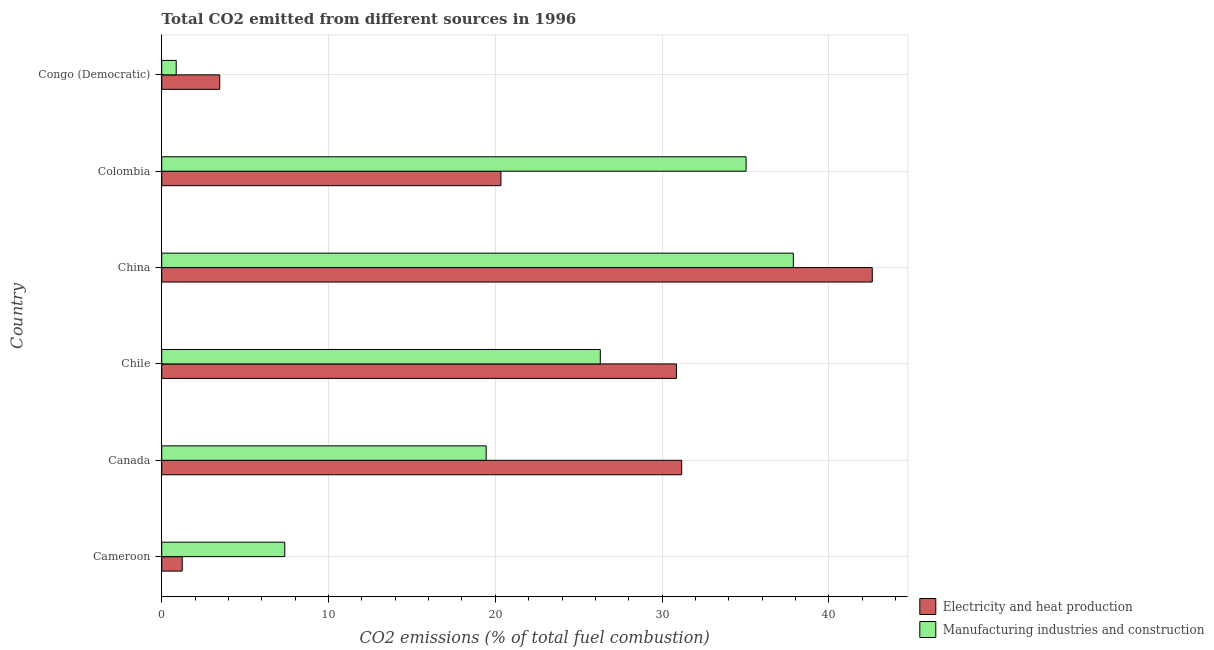How many different coloured bars are there?
Offer a very short reply. 2. How many bars are there on the 3rd tick from the bottom?
Provide a succinct answer. 2. What is the label of the 5th group of bars from the top?
Provide a short and direct response. Canada. In how many cases, is the number of bars for a given country not equal to the number of legend labels?
Keep it short and to the point. 0. What is the co2 emissions due to electricity and heat production in China?
Offer a very short reply. 42.59. Across all countries, what is the maximum co2 emissions due to electricity and heat production?
Make the answer very short. 42.59. Across all countries, what is the minimum co2 emissions due to electricity and heat production?
Give a very brief answer. 1.23. In which country was the co2 emissions due to manufacturing industries maximum?
Provide a short and direct response. China. In which country was the co2 emissions due to manufacturing industries minimum?
Offer a very short reply. Congo (Democratic). What is the total co2 emissions due to manufacturing industries in the graph?
Your answer should be very brief. 126.88. What is the difference between the co2 emissions due to electricity and heat production in Chile and that in China?
Keep it short and to the point. -11.74. What is the difference between the co2 emissions due to electricity and heat production in Cameroon and the co2 emissions due to manufacturing industries in Congo (Democratic)?
Offer a very short reply. 0.36. What is the average co2 emissions due to electricity and heat production per country?
Ensure brevity in your answer.  21.61. What is the difference between the co2 emissions due to electricity and heat production and co2 emissions due to manufacturing industries in Cameroon?
Offer a very short reply. -6.15. What is the ratio of the co2 emissions due to electricity and heat production in Colombia to that in Congo (Democratic)?
Offer a very short reply. 5.85. Is the co2 emissions due to manufacturing industries in China less than that in Colombia?
Your answer should be very brief. No. Is the difference between the co2 emissions due to electricity and heat production in China and Congo (Democratic) greater than the difference between the co2 emissions due to manufacturing industries in China and Congo (Democratic)?
Ensure brevity in your answer.  Yes. What is the difference between the highest and the second highest co2 emissions due to manufacturing industries?
Make the answer very short. 2.83. What is the difference between the highest and the lowest co2 emissions due to manufacturing industries?
Your answer should be very brief. 36.99. In how many countries, is the co2 emissions due to manufacturing industries greater than the average co2 emissions due to manufacturing industries taken over all countries?
Your response must be concise. 3. What does the 1st bar from the top in Canada represents?
Provide a short and direct response. Manufacturing industries and construction. What does the 2nd bar from the bottom in Canada represents?
Ensure brevity in your answer.  Manufacturing industries and construction. What is the difference between two consecutive major ticks on the X-axis?
Give a very brief answer. 10. Does the graph contain grids?
Your answer should be very brief. Yes. Where does the legend appear in the graph?
Make the answer very short. Bottom right. How many legend labels are there?
Give a very brief answer. 2. How are the legend labels stacked?
Provide a succinct answer. Vertical. What is the title of the graph?
Offer a terse response. Total CO2 emitted from different sources in 1996. Does "Education" appear as one of the legend labels in the graph?
Offer a very short reply. No. What is the label or title of the X-axis?
Your answer should be compact. CO2 emissions (% of total fuel combustion). What is the label or title of the Y-axis?
Keep it short and to the point. Country. What is the CO2 emissions (% of total fuel combustion) of Electricity and heat production in Cameroon?
Make the answer very short. 1.23. What is the CO2 emissions (% of total fuel combustion) in Manufacturing industries and construction in Cameroon?
Offer a terse response. 7.38. What is the CO2 emissions (% of total fuel combustion) of Electricity and heat production in Canada?
Your response must be concise. 31.17. What is the CO2 emissions (% of total fuel combustion) in Manufacturing industries and construction in Canada?
Your answer should be very brief. 19.45. What is the CO2 emissions (% of total fuel combustion) in Electricity and heat production in Chile?
Offer a very short reply. 30.85. What is the CO2 emissions (% of total fuel combustion) in Manufacturing industries and construction in Chile?
Your response must be concise. 26.29. What is the CO2 emissions (% of total fuel combustion) of Electricity and heat production in China?
Your answer should be very brief. 42.59. What is the CO2 emissions (% of total fuel combustion) in Manufacturing industries and construction in China?
Ensure brevity in your answer.  37.86. What is the CO2 emissions (% of total fuel combustion) in Electricity and heat production in Colombia?
Provide a succinct answer. 20.33. What is the CO2 emissions (% of total fuel combustion) in Manufacturing industries and construction in Colombia?
Offer a terse response. 35.03. What is the CO2 emissions (% of total fuel combustion) of Electricity and heat production in Congo (Democratic)?
Provide a short and direct response. 3.48. What is the CO2 emissions (% of total fuel combustion) of Manufacturing industries and construction in Congo (Democratic)?
Provide a succinct answer. 0.87. Across all countries, what is the maximum CO2 emissions (% of total fuel combustion) in Electricity and heat production?
Your answer should be compact. 42.59. Across all countries, what is the maximum CO2 emissions (% of total fuel combustion) of Manufacturing industries and construction?
Ensure brevity in your answer.  37.86. Across all countries, what is the minimum CO2 emissions (% of total fuel combustion) in Electricity and heat production?
Ensure brevity in your answer.  1.23. Across all countries, what is the minimum CO2 emissions (% of total fuel combustion) of Manufacturing industries and construction?
Give a very brief answer. 0.87. What is the total CO2 emissions (% of total fuel combustion) in Electricity and heat production in the graph?
Provide a short and direct response. 129.66. What is the total CO2 emissions (% of total fuel combustion) of Manufacturing industries and construction in the graph?
Provide a succinct answer. 126.88. What is the difference between the CO2 emissions (% of total fuel combustion) of Electricity and heat production in Cameroon and that in Canada?
Your answer should be very brief. -29.94. What is the difference between the CO2 emissions (% of total fuel combustion) in Manufacturing industries and construction in Cameroon and that in Canada?
Ensure brevity in your answer.  -12.07. What is the difference between the CO2 emissions (% of total fuel combustion) in Electricity and heat production in Cameroon and that in Chile?
Offer a terse response. -29.63. What is the difference between the CO2 emissions (% of total fuel combustion) of Manufacturing industries and construction in Cameroon and that in Chile?
Give a very brief answer. -18.91. What is the difference between the CO2 emissions (% of total fuel combustion) of Electricity and heat production in Cameroon and that in China?
Your answer should be very brief. -41.37. What is the difference between the CO2 emissions (% of total fuel combustion) of Manufacturing industries and construction in Cameroon and that in China?
Keep it short and to the point. -30.49. What is the difference between the CO2 emissions (% of total fuel combustion) in Electricity and heat production in Cameroon and that in Colombia?
Provide a succinct answer. -19.1. What is the difference between the CO2 emissions (% of total fuel combustion) of Manufacturing industries and construction in Cameroon and that in Colombia?
Your answer should be very brief. -27.66. What is the difference between the CO2 emissions (% of total fuel combustion) in Electricity and heat production in Cameroon and that in Congo (Democratic)?
Give a very brief answer. -2.25. What is the difference between the CO2 emissions (% of total fuel combustion) of Manufacturing industries and construction in Cameroon and that in Congo (Democratic)?
Make the answer very short. 6.51. What is the difference between the CO2 emissions (% of total fuel combustion) in Electricity and heat production in Canada and that in Chile?
Provide a short and direct response. 0.32. What is the difference between the CO2 emissions (% of total fuel combustion) in Manufacturing industries and construction in Canada and that in Chile?
Offer a terse response. -6.84. What is the difference between the CO2 emissions (% of total fuel combustion) of Electricity and heat production in Canada and that in China?
Your answer should be very brief. -11.42. What is the difference between the CO2 emissions (% of total fuel combustion) in Manufacturing industries and construction in Canada and that in China?
Provide a succinct answer. -18.41. What is the difference between the CO2 emissions (% of total fuel combustion) of Electricity and heat production in Canada and that in Colombia?
Your response must be concise. 10.84. What is the difference between the CO2 emissions (% of total fuel combustion) in Manufacturing industries and construction in Canada and that in Colombia?
Give a very brief answer. -15.58. What is the difference between the CO2 emissions (% of total fuel combustion) in Electricity and heat production in Canada and that in Congo (Democratic)?
Ensure brevity in your answer.  27.69. What is the difference between the CO2 emissions (% of total fuel combustion) in Manufacturing industries and construction in Canada and that in Congo (Democratic)?
Give a very brief answer. 18.58. What is the difference between the CO2 emissions (% of total fuel combustion) of Electricity and heat production in Chile and that in China?
Make the answer very short. -11.74. What is the difference between the CO2 emissions (% of total fuel combustion) of Manufacturing industries and construction in Chile and that in China?
Your answer should be very brief. -11.57. What is the difference between the CO2 emissions (% of total fuel combustion) in Electricity and heat production in Chile and that in Colombia?
Offer a very short reply. 10.52. What is the difference between the CO2 emissions (% of total fuel combustion) of Manufacturing industries and construction in Chile and that in Colombia?
Give a very brief answer. -8.74. What is the difference between the CO2 emissions (% of total fuel combustion) in Electricity and heat production in Chile and that in Congo (Democratic)?
Keep it short and to the point. 27.38. What is the difference between the CO2 emissions (% of total fuel combustion) in Manufacturing industries and construction in Chile and that in Congo (Democratic)?
Your response must be concise. 25.42. What is the difference between the CO2 emissions (% of total fuel combustion) in Electricity and heat production in China and that in Colombia?
Your answer should be very brief. 22.26. What is the difference between the CO2 emissions (% of total fuel combustion) in Manufacturing industries and construction in China and that in Colombia?
Give a very brief answer. 2.83. What is the difference between the CO2 emissions (% of total fuel combustion) in Electricity and heat production in China and that in Congo (Democratic)?
Provide a succinct answer. 39.12. What is the difference between the CO2 emissions (% of total fuel combustion) in Manufacturing industries and construction in China and that in Congo (Democratic)?
Give a very brief answer. 36.99. What is the difference between the CO2 emissions (% of total fuel combustion) of Electricity and heat production in Colombia and that in Congo (Democratic)?
Your answer should be compact. 16.86. What is the difference between the CO2 emissions (% of total fuel combustion) of Manufacturing industries and construction in Colombia and that in Congo (Democratic)?
Your response must be concise. 34.16. What is the difference between the CO2 emissions (% of total fuel combustion) in Electricity and heat production in Cameroon and the CO2 emissions (% of total fuel combustion) in Manufacturing industries and construction in Canada?
Offer a very short reply. -18.22. What is the difference between the CO2 emissions (% of total fuel combustion) in Electricity and heat production in Cameroon and the CO2 emissions (% of total fuel combustion) in Manufacturing industries and construction in Chile?
Provide a succinct answer. -25.06. What is the difference between the CO2 emissions (% of total fuel combustion) of Electricity and heat production in Cameroon and the CO2 emissions (% of total fuel combustion) of Manufacturing industries and construction in China?
Offer a terse response. -36.63. What is the difference between the CO2 emissions (% of total fuel combustion) in Electricity and heat production in Cameroon and the CO2 emissions (% of total fuel combustion) in Manufacturing industries and construction in Colombia?
Offer a very short reply. -33.8. What is the difference between the CO2 emissions (% of total fuel combustion) in Electricity and heat production in Cameroon and the CO2 emissions (% of total fuel combustion) in Manufacturing industries and construction in Congo (Democratic)?
Your answer should be compact. 0.36. What is the difference between the CO2 emissions (% of total fuel combustion) of Electricity and heat production in Canada and the CO2 emissions (% of total fuel combustion) of Manufacturing industries and construction in Chile?
Provide a succinct answer. 4.88. What is the difference between the CO2 emissions (% of total fuel combustion) of Electricity and heat production in Canada and the CO2 emissions (% of total fuel combustion) of Manufacturing industries and construction in China?
Provide a short and direct response. -6.69. What is the difference between the CO2 emissions (% of total fuel combustion) of Electricity and heat production in Canada and the CO2 emissions (% of total fuel combustion) of Manufacturing industries and construction in Colombia?
Your response must be concise. -3.86. What is the difference between the CO2 emissions (% of total fuel combustion) in Electricity and heat production in Canada and the CO2 emissions (% of total fuel combustion) in Manufacturing industries and construction in Congo (Democratic)?
Provide a short and direct response. 30.3. What is the difference between the CO2 emissions (% of total fuel combustion) in Electricity and heat production in Chile and the CO2 emissions (% of total fuel combustion) in Manufacturing industries and construction in China?
Give a very brief answer. -7.01. What is the difference between the CO2 emissions (% of total fuel combustion) in Electricity and heat production in Chile and the CO2 emissions (% of total fuel combustion) in Manufacturing industries and construction in Colombia?
Ensure brevity in your answer.  -4.18. What is the difference between the CO2 emissions (% of total fuel combustion) of Electricity and heat production in Chile and the CO2 emissions (% of total fuel combustion) of Manufacturing industries and construction in Congo (Democratic)?
Your answer should be compact. 29.99. What is the difference between the CO2 emissions (% of total fuel combustion) of Electricity and heat production in China and the CO2 emissions (% of total fuel combustion) of Manufacturing industries and construction in Colombia?
Your answer should be very brief. 7.56. What is the difference between the CO2 emissions (% of total fuel combustion) of Electricity and heat production in China and the CO2 emissions (% of total fuel combustion) of Manufacturing industries and construction in Congo (Democratic)?
Your answer should be very brief. 41.73. What is the difference between the CO2 emissions (% of total fuel combustion) in Electricity and heat production in Colombia and the CO2 emissions (% of total fuel combustion) in Manufacturing industries and construction in Congo (Democratic)?
Give a very brief answer. 19.46. What is the average CO2 emissions (% of total fuel combustion) in Electricity and heat production per country?
Provide a short and direct response. 21.61. What is the average CO2 emissions (% of total fuel combustion) in Manufacturing industries and construction per country?
Give a very brief answer. 21.15. What is the difference between the CO2 emissions (% of total fuel combustion) of Electricity and heat production and CO2 emissions (% of total fuel combustion) of Manufacturing industries and construction in Cameroon?
Your answer should be very brief. -6.15. What is the difference between the CO2 emissions (% of total fuel combustion) in Electricity and heat production and CO2 emissions (% of total fuel combustion) in Manufacturing industries and construction in Canada?
Provide a short and direct response. 11.72. What is the difference between the CO2 emissions (% of total fuel combustion) of Electricity and heat production and CO2 emissions (% of total fuel combustion) of Manufacturing industries and construction in Chile?
Keep it short and to the point. 4.56. What is the difference between the CO2 emissions (% of total fuel combustion) in Electricity and heat production and CO2 emissions (% of total fuel combustion) in Manufacturing industries and construction in China?
Make the answer very short. 4.73. What is the difference between the CO2 emissions (% of total fuel combustion) in Electricity and heat production and CO2 emissions (% of total fuel combustion) in Manufacturing industries and construction in Colombia?
Offer a very short reply. -14.7. What is the difference between the CO2 emissions (% of total fuel combustion) in Electricity and heat production and CO2 emissions (% of total fuel combustion) in Manufacturing industries and construction in Congo (Democratic)?
Give a very brief answer. 2.61. What is the ratio of the CO2 emissions (% of total fuel combustion) of Electricity and heat production in Cameroon to that in Canada?
Provide a short and direct response. 0.04. What is the ratio of the CO2 emissions (% of total fuel combustion) of Manufacturing industries and construction in Cameroon to that in Canada?
Provide a succinct answer. 0.38. What is the ratio of the CO2 emissions (% of total fuel combustion) in Electricity and heat production in Cameroon to that in Chile?
Your answer should be compact. 0.04. What is the ratio of the CO2 emissions (% of total fuel combustion) of Manufacturing industries and construction in Cameroon to that in Chile?
Ensure brevity in your answer.  0.28. What is the ratio of the CO2 emissions (% of total fuel combustion) in Electricity and heat production in Cameroon to that in China?
Offer a terse response. 0.03. What is the ratio of the CO2 emissions (% of total fuel combustion) in Manufacturing industries and construction in Cameroon to that in China?
Provide a succinct answer. 0.19. What is the ratio of the CO2 emissions (% of total fuel combustion) in Electricity and heat production in Cameroon to that in Colombia?
Your answer should be very brief. 0.06. What is the ratio of the CO2 emissions (% of total fuel combustion) in Manufacturing industries and construction in Cameroon to that in Colombia?
Your answer should be very brief. 0.21. What is the ratio of the CO2 emissions (% of total fuel combustion) in Electricity and heat production in Cameroon to that in Congo (Democratic)?
Keep it short and to the point. 0.35. What is the ratio of the CO2 emissions (% of total fuel combustion) in Manufacturing industries and construction in Cameroon to that in Congo (Democratic)?
Give a very brief answer. 8.48. What is the ratio of the CO2 emissions (% of total fuel combustion) of Electricity and heat production in Canada to that in Chile?
Offer a very short reply. 1.01. What is the ratio of the CO2 emissions (% of total fuel combustion) of Manufacturing industries and construction in Canada to that in Chile?
Your answer should be compact. 0.74. What is the ratio of the CO2 emissions (% of total fuel combustion) of Electricity and heat production in Canada to that in China?
Make the answer very short. 0.73. What is the ratio of the CO2 emissions (% of total fuel combustion) in Manufacturing industries and construction in Canada to that in China?
Your answer should be compact. 0.51. What is the ratio of the CO2 emissions (% of total fuel combustion) in Electricity and heat production in Canada to that in Colombia?
Your answer should be compact. 1.53. What is the ratio of the CO2 emissions (% of total fuel combustion) of Manufacturing industries and construction in Canada to that in Colombia?
Keep it short and to the point. 0.56. What is the ratio of the CO2 emissions (% of total fuel combustion) in Electricity and heat production in Canada to that in Congo (Democratic)?
Keep it short and to the point. 8.96. What is the ratio of the CO2 emissions (% of total fuel combustion) of Manufacturing industries and construction in Canada to that in Congo (Democratic)?
Your answer should be compact. 22.37. What is the ratio of the CO2 emissions (% of total fuel combustion) of Electricity and heat production in Chile to that in China?
Your response must be concise. 0.72. What is the ratio of the CO2 emissions (% of total fuel combustion) in Manufacturing industries and construction in Chile to that in China?
Provide a short and direct response. 0.69. What is the ratio of the CO2 emissions (% of total fuel combustion) of Electricity and heat production in Chile to that in Colombia?
Provide a succinct answer. 1.52. What is the ratio of the CO2 emissions (% of total fuel combustion) of Manufacturing industries and construction in Chile to that in Colombia?
Provide a short and direct response. 0.75. What is the ratio of the CO2 emissions (% of total fuel combustion) in Electricity and heat production in Chile to that in Congo (Democratic)?
Keep it short and to the point. 8.87. What is the ratio of the CO2 emissions (% of total fuel combustion) in Manufacturing industries and construction in Chile to that in Congo (Democratic)?
Offer a terse response. 30.23. What is the ratio of the CO2 emissions (% of total fuel combustion) in Electricity and heat production in China to that in Colombia?
Give a very brief answer. 2.09. What is the ratio of the CO2 emissions (% of total fuel combustion) of Manufacturing industries and construction in China to that in Colombia?
Give a very brief answer. 1.08. What is the ratio of the CO2 emissions (% of total fuel combustion) in Electricity and heat production in China to that in Congo (Democratic)?
Ensure brevity in your answer.  12.25. What is the ratio of the CO2 emissions (% of total fuel combustion) of Manufacturing industries and construction in China to that in Congo (Democratic)?
Offer a terse response. 43.54. What is the ratio of the CO2 emissions (% of total fuel combustion) in Electricity and heat production in Colombia to that in Congo (Democratic)?
Keep it short and to the point. 5.85. What is the ratio of the CO2 emissions (% of total fuel combustion) in Manufacturing industries and construction in Colombia to that in Congo (Democratic)?
Offer a very short reply. 40.29. What is the difference between the highest and the second highest CO2 emissions (% of total fuel combustion) in Electricity and heat production?
Offer a very short reply. 11.42. What is the difference between the highest and the second highest CO2 emissions (% of total fuel combustion) of Manufacturing industries and construction?
Offer a terse response. 2.83. What is the difference between the highest and the lowest CO2 emissions (% of total fuel combustion) of Electricity and heat production?
Offer a terse response. 41.37. What is the difference between the highest and the lowest CO2 emissions (% of total fuel combustion) in Manufacturing industries and construction?
Your response must be concise. 36.99. 